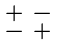<formula> <loc_0><loc_0><loc_500><loc_500>\begin{smallmatrix} + & - \\ - & + \end{smallmatrix}</formula> 